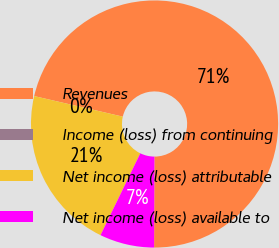Convert chart. <chart><loc_0><loc_0><loc_500><loc_500><pie_chart><fcel>Revenues<fcel>Income (loss) from continuing<fcel>Net income (loss) attributable<fcel>Net income (loss) available to<nl><fcel>71.42%<fcel>0.0%<fcel>21.43%<fcel>7.14%<nl></chart> 